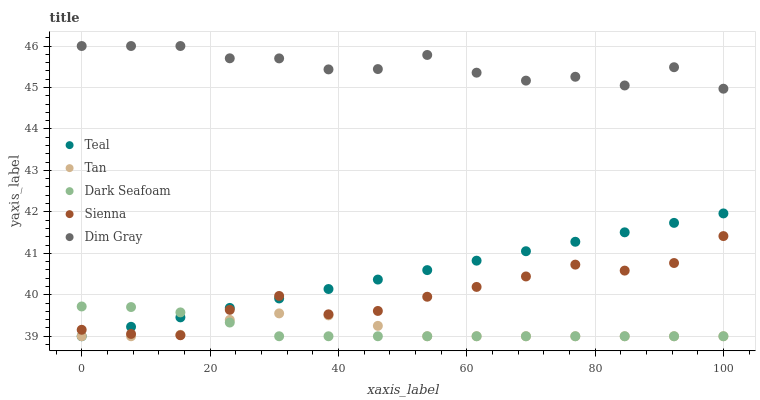Does Tan have the minimum area under the curve?
Answer yes or no. Yes. Does Dim Gray have the maximum area under the curve?
Answer yes or no. Yes. Does Dim Gray have the minimum area under the curve?
Answer yes or no. No. Does Tan have the maximum area under the curve?
Answer yes or no. No. Is Teal the smoothest?
Answer yes or no. Yes. Is Dim Gray the roughest?
Answer yes or no. Yes. Is Tan the smoothest?
Answer yes or no. No. Is Tan the roughest?
Answer yes or no. No. Does Tan have the lowest value?
Answer yes or no. Yes. Does Dim Gray have the lowest value?
Answer yes or no. No. Does Dim Gray have the highest value?
Answer yes or no. Yes. Does Tan have the highest value?
Answer yes or no. No. Is Tan less than Dim Gray?
Answer yes or no. Yes. Is Dim Gray greater than Teal?
Answer yes or no. Yes. Does Dark Seafoam intersect Sienna?
Answer yes or no. Yes. Is Dark Seafoam less than Sienna?
Answer yes or no. No. Is Dark Seafoam greater than Sienna?
Answer yes or no. No. Does Tan intersect Dim Gray?
Answer yes or no. No. 